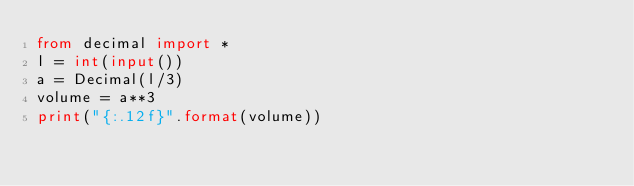<code> <loc_0><loc_0><loc_500><loc_500><_Python_>from decimal import *
l = int(input())
a = Decimal(l/3)
volume = a**3
print("{:.12f}".format(volume))
</code> 